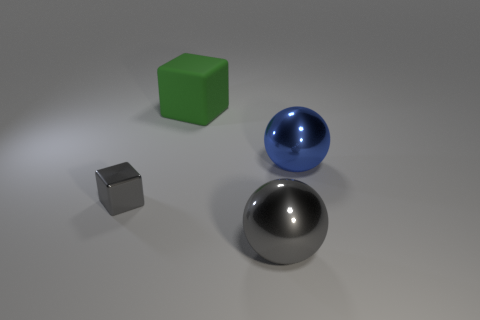Add 2 large metal balls. How many objects exist? 6 Subtract 0 brown cylinders. How many objects are left? 4 Subtract all gray spheres. Subtract all green rubber cubes. How many objects are left? 2 Add 2 large gray things. How many large gray things are left? 3 Add 3 small metal blocks. How many small metal blocks exist? 4 